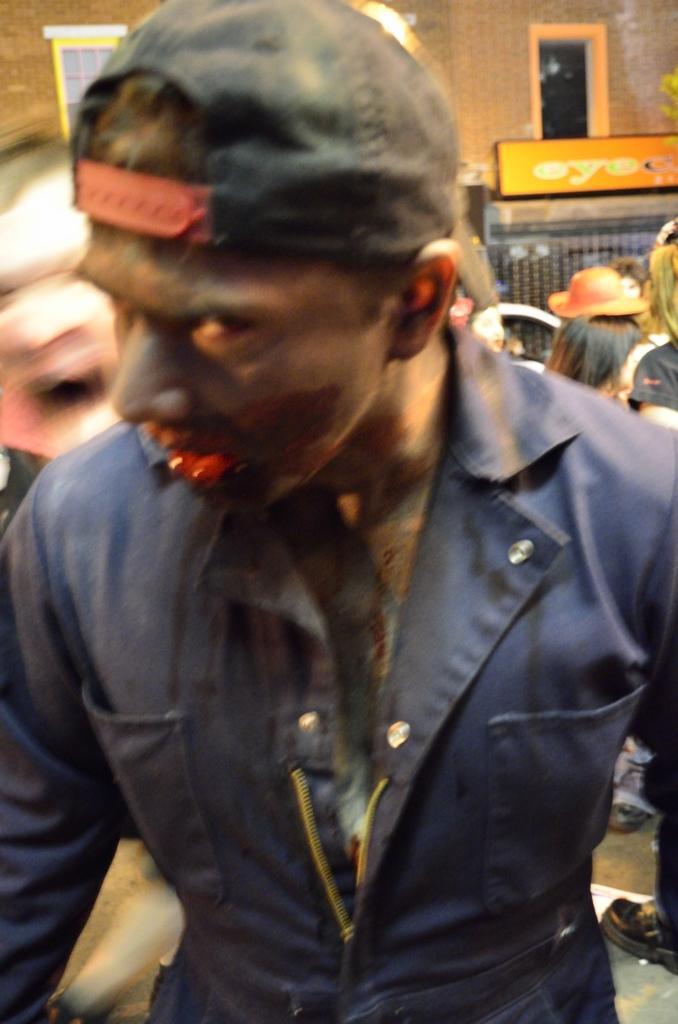Could you give a brief overview of what you see in this image? As we can see in the image in the front there is a man wearing black color jacket. In the background there are few people, wall, banner and there is a window. 